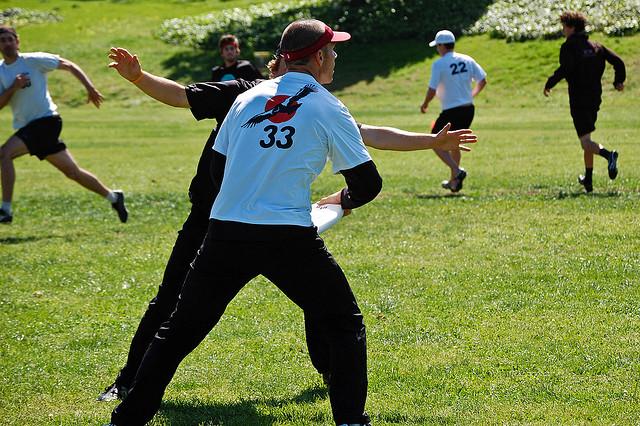Are the men in shorts?
Be succinct. Yes. How many men are wearing white shirts?
Be succinct. 3. What sport is this?
Be succinct. Frisbee. What is the shape of the Frisbee?
Concise answer only. Round. What animal is on the shirt?
Give a very brief answer. Eagle. 